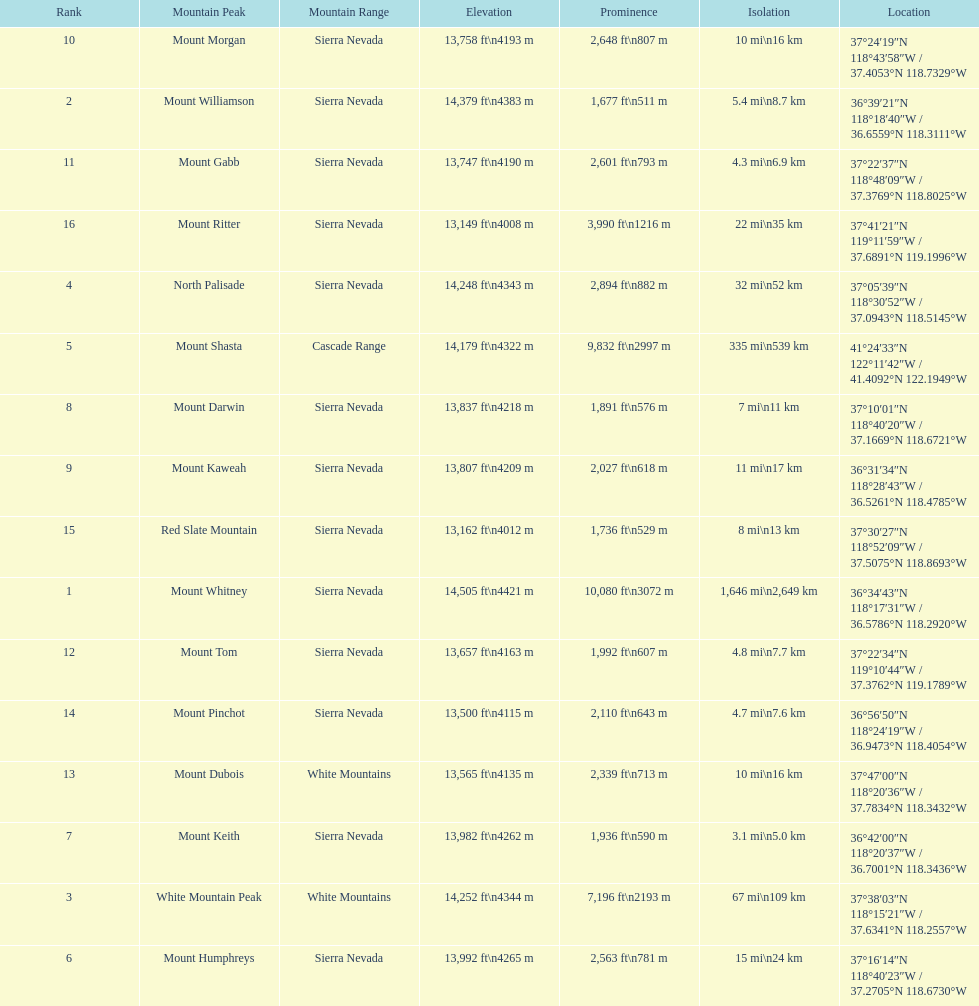What is the only mountain peak listed for the cascade range? Mount Shasta. 